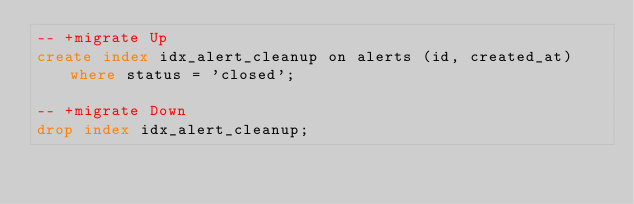<code> <loc_0><loc_0><loc_500><loc_500><_SQL_>-- +migrate Up
create index idx_alert_cleanup on alerts (id, created_at) where status = 'closed';

-- +migrate Down
drop index idx_alert_cleanup;
</code> 